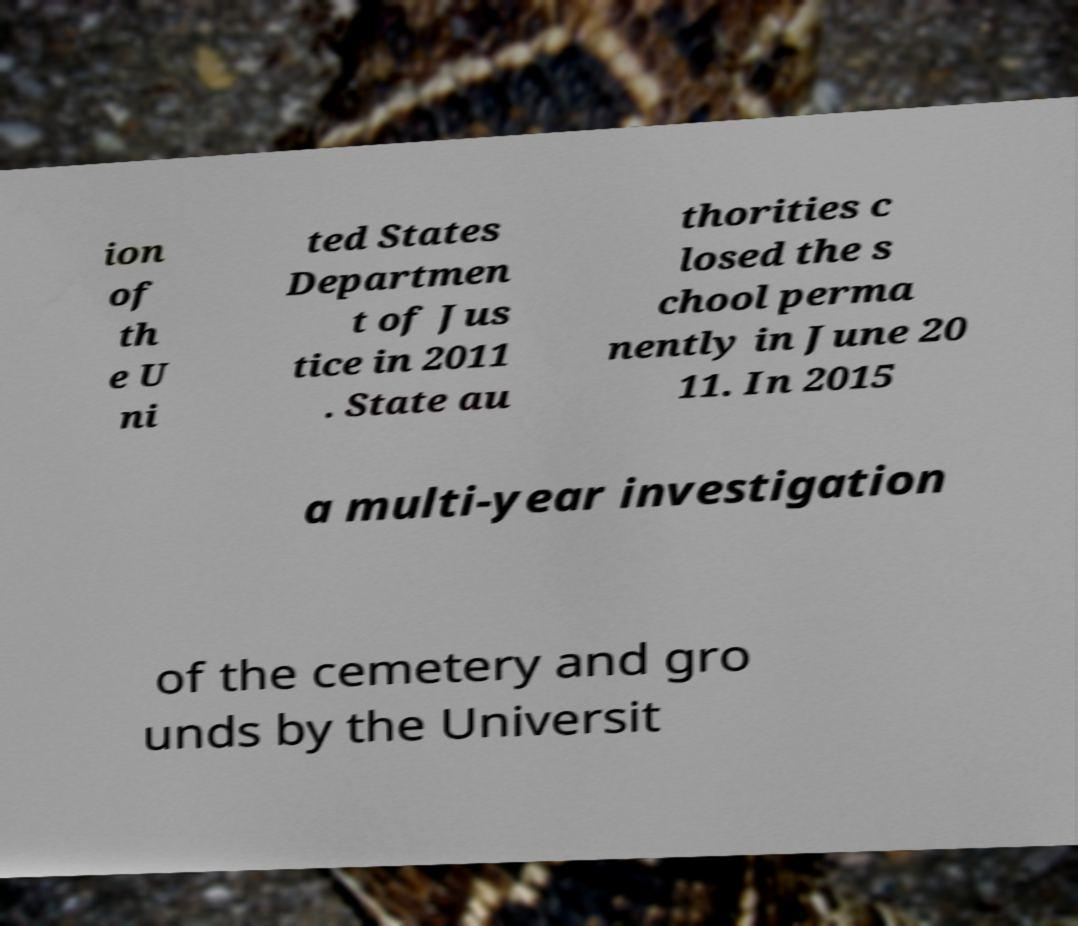Please read and relay the text visible in this image. What does it say? ion of th e U ni ted States Departmen t of Jus tice in 2011 . State au thorities c losed the s chool perma nently in June 20 11. In 2015 a multi-year investigation of the cemetery and gro unds by the Universit 